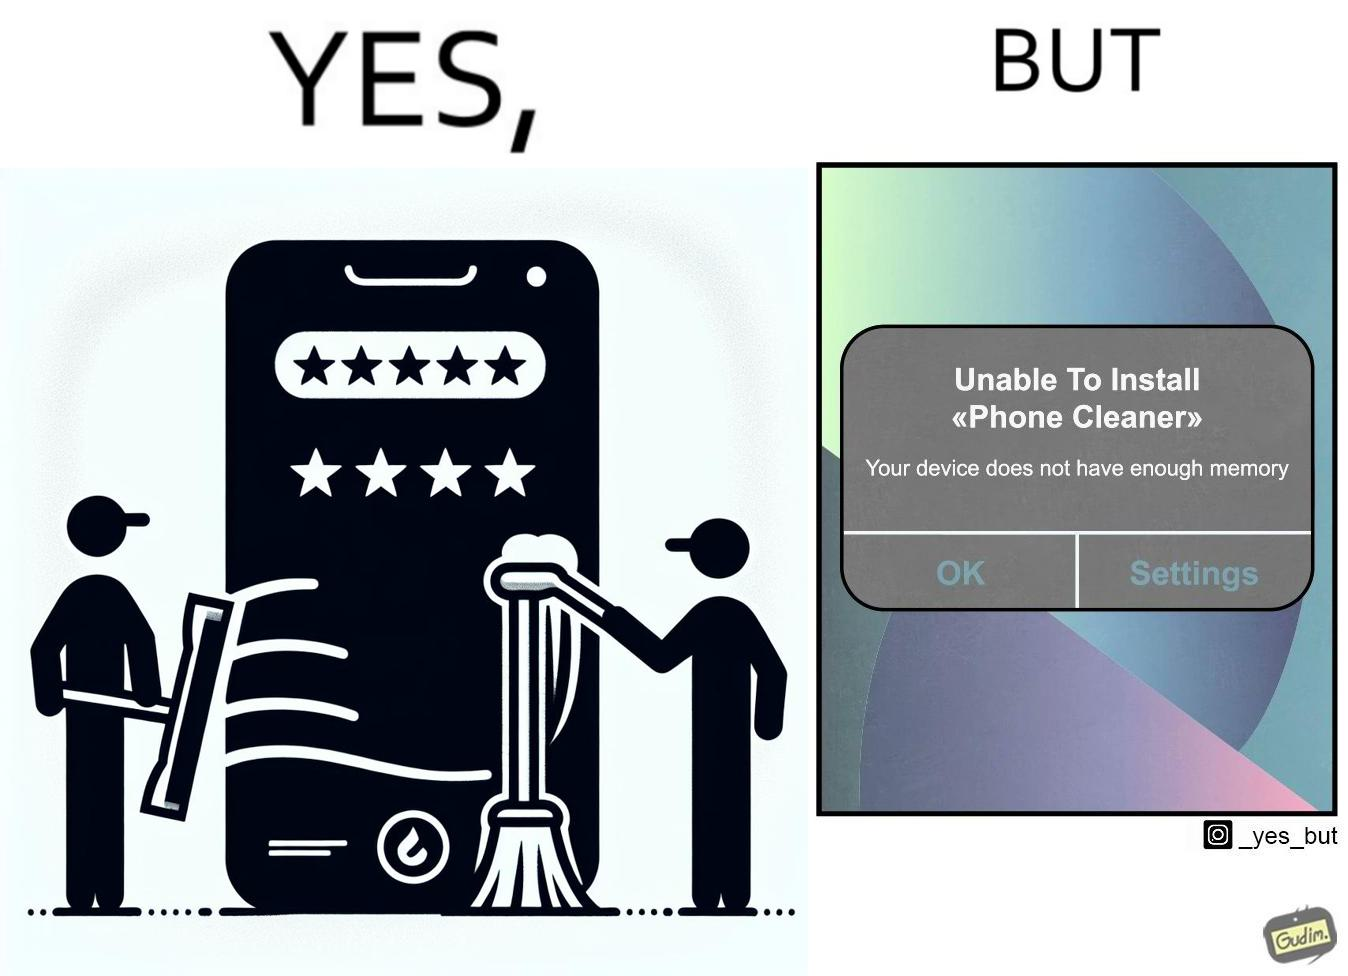Explain the humor or irony in this image. The image is ironical, as to clear the phone's memory using phone cleaner app, one has to install it, but that is not possible in turn due to the phone memory being full. 